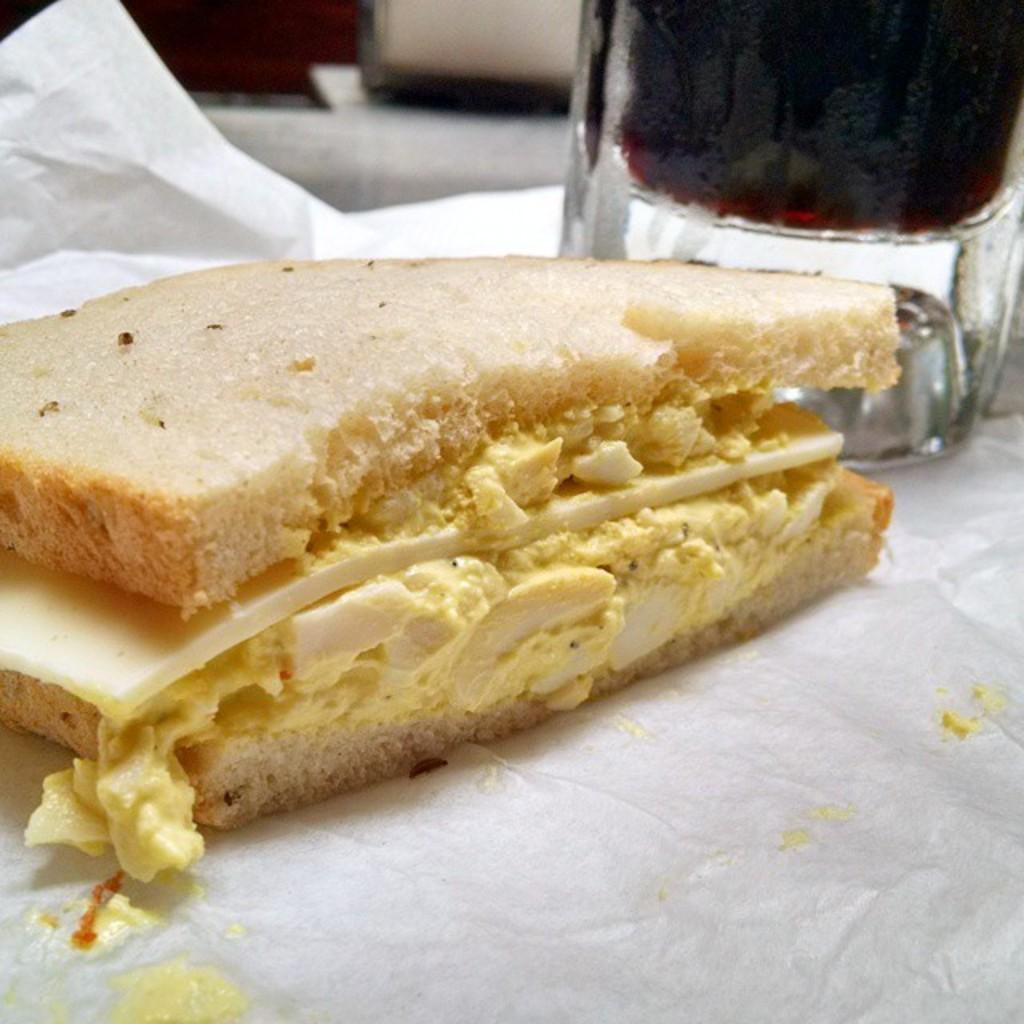What is on the paper in the image? There is food on a paper in the image. What else can be seen in the image besides the food on the paper? There is a glass in the image. How many tomatoes are on the page in the image? There is no page or tomatoes present in the image. What type of behavior can be observed in the image? There is no behavior depicted in the image, as it only shows food on a paper and a glass. 